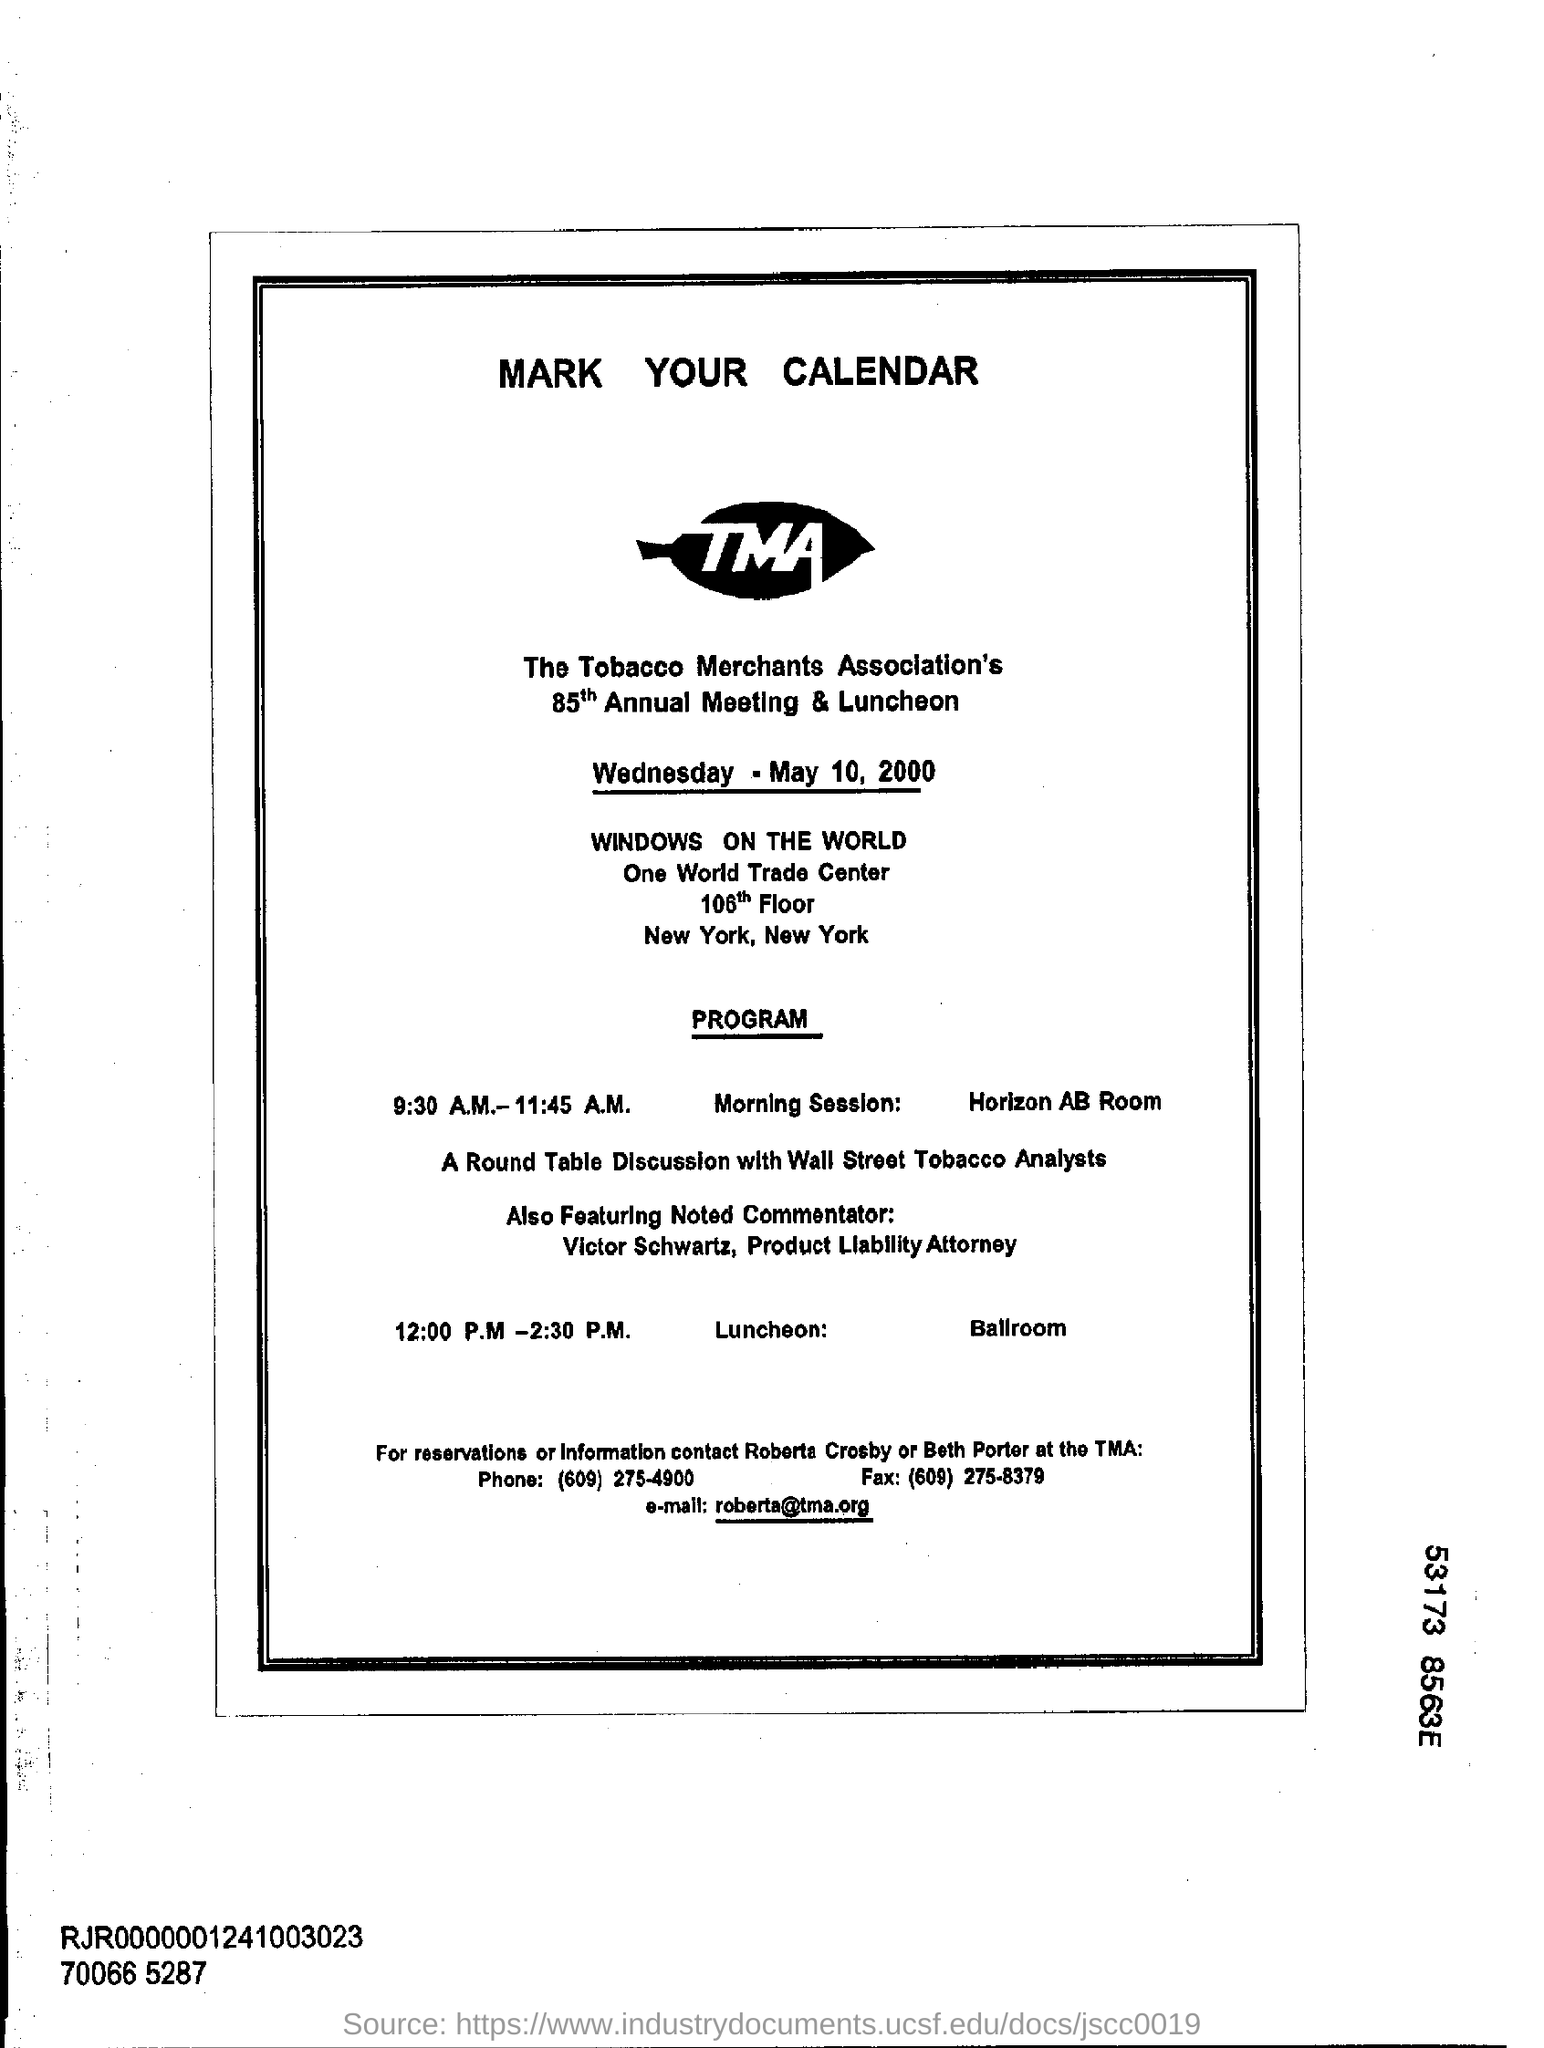Point out several critical features in this image. The Round Table Conference is being attended by Wall Street tobacco analysts. The Annual Meeting & Luncheon will be held on Wednesday, May 10, 2000. The contact email is "[roberta@tma.org](mailto:roberta@tma.org)". It has been announced that Victor Schwartz, a noted commentator, will be featured in the near future. The location of the morning session has been announced as Horizon AB Room. 